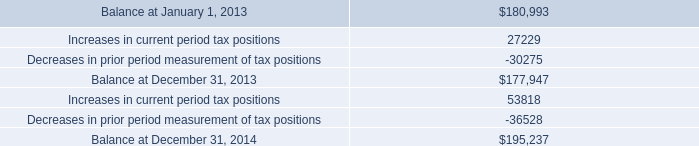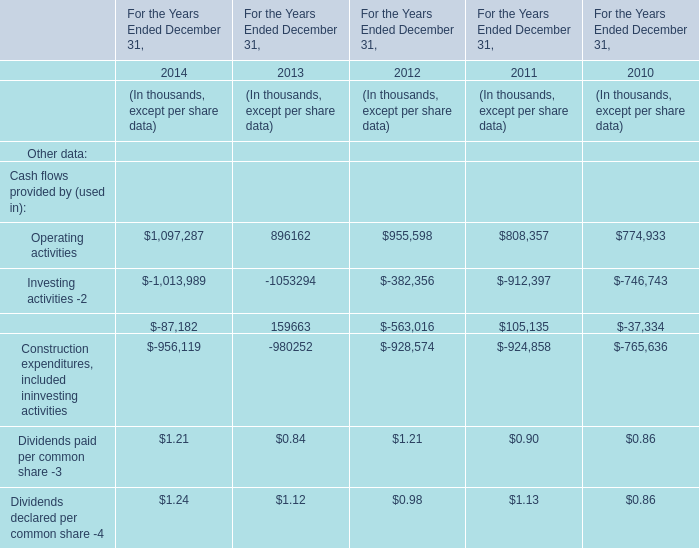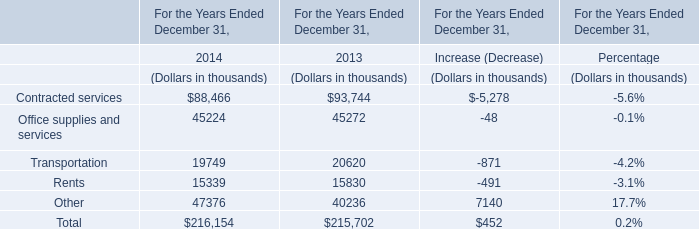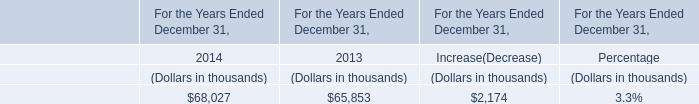by how much did company 2019s gross liability , excluding interest and penalties , for unrecognized tax benefits increase from 2014 to 2014? 
Computations: ((195237 - 177947) / 177947)
Answer: 0.09716. 